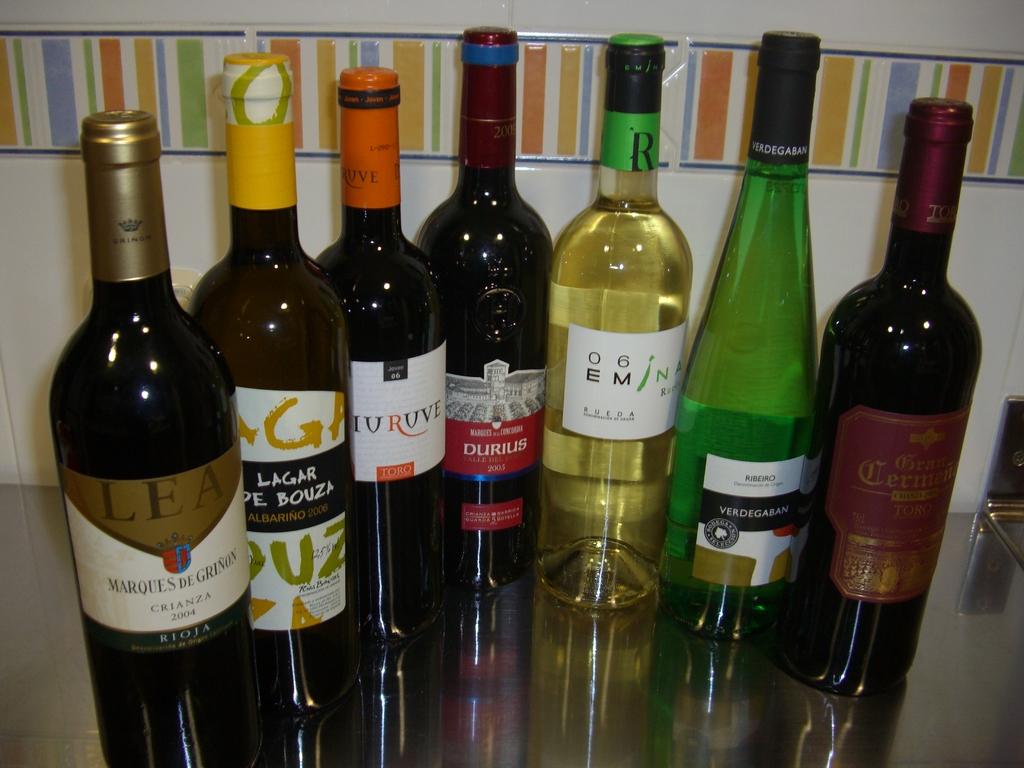What brand is on the label of the wine farthest to the left?
Your answer should be compact. Lea. What brand is the first bottle on the right?
Your answer should be compact. Toro. 